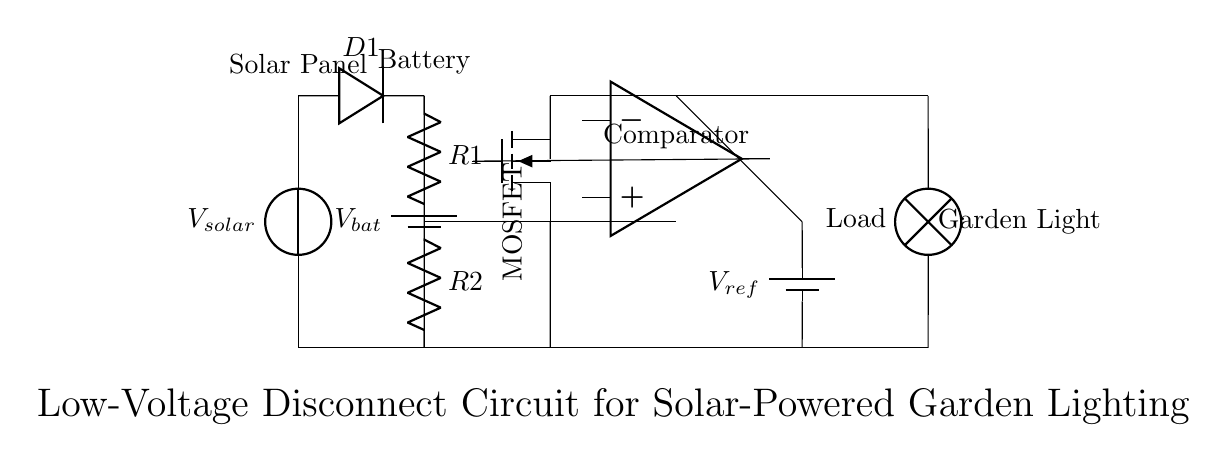What type of component is D1? D1 is a diode, which is used to allow current to flow in one direction while blocking it in the opposite direction. This is shown as the symbol for a diode in the circuit diagram.
Answer: diode What is the purpose of the comparator? The comparator compares the voltage at its inverting and non-inverting inputs to determine whether to turn on or off the MOSFET, thus controlling the load. This is a critical function in a low-voltage disconnect circuit to protect the battery.
Answer: control MOSFET How many resistors are present in the circuit? There are two resistors labeled R1 and R2 connected in series to form a voltage divider that provides a reference voltage to the comparator.
Answer: two What is the function of the MOSFET in this circuit? The MOSFET acts as a switch that controls the flow of current to the garden light based on the output from the comparator, enabling or disabling the load as necessary.
Answer: switch What is the reference voltage source in this circuit? The reference voltage source is a battery labeled Vref. It provides a stable voltage to compare against the voltage from the voltage divider.
Answer: Vref What happens when the battery voltage drops below a certain threshold? When the battery voltage drops below the threshold set by the comparator, the comparator output signals the MOSFET to turn off, disconnecting the load to prevent battery damage.
Answer: disconnect load At what position is the solar panel connected? The solar panel is connected at the top left of the circuit, labeled as Vsolar, providing energy to the system and charging the battery.
Answer: top left 